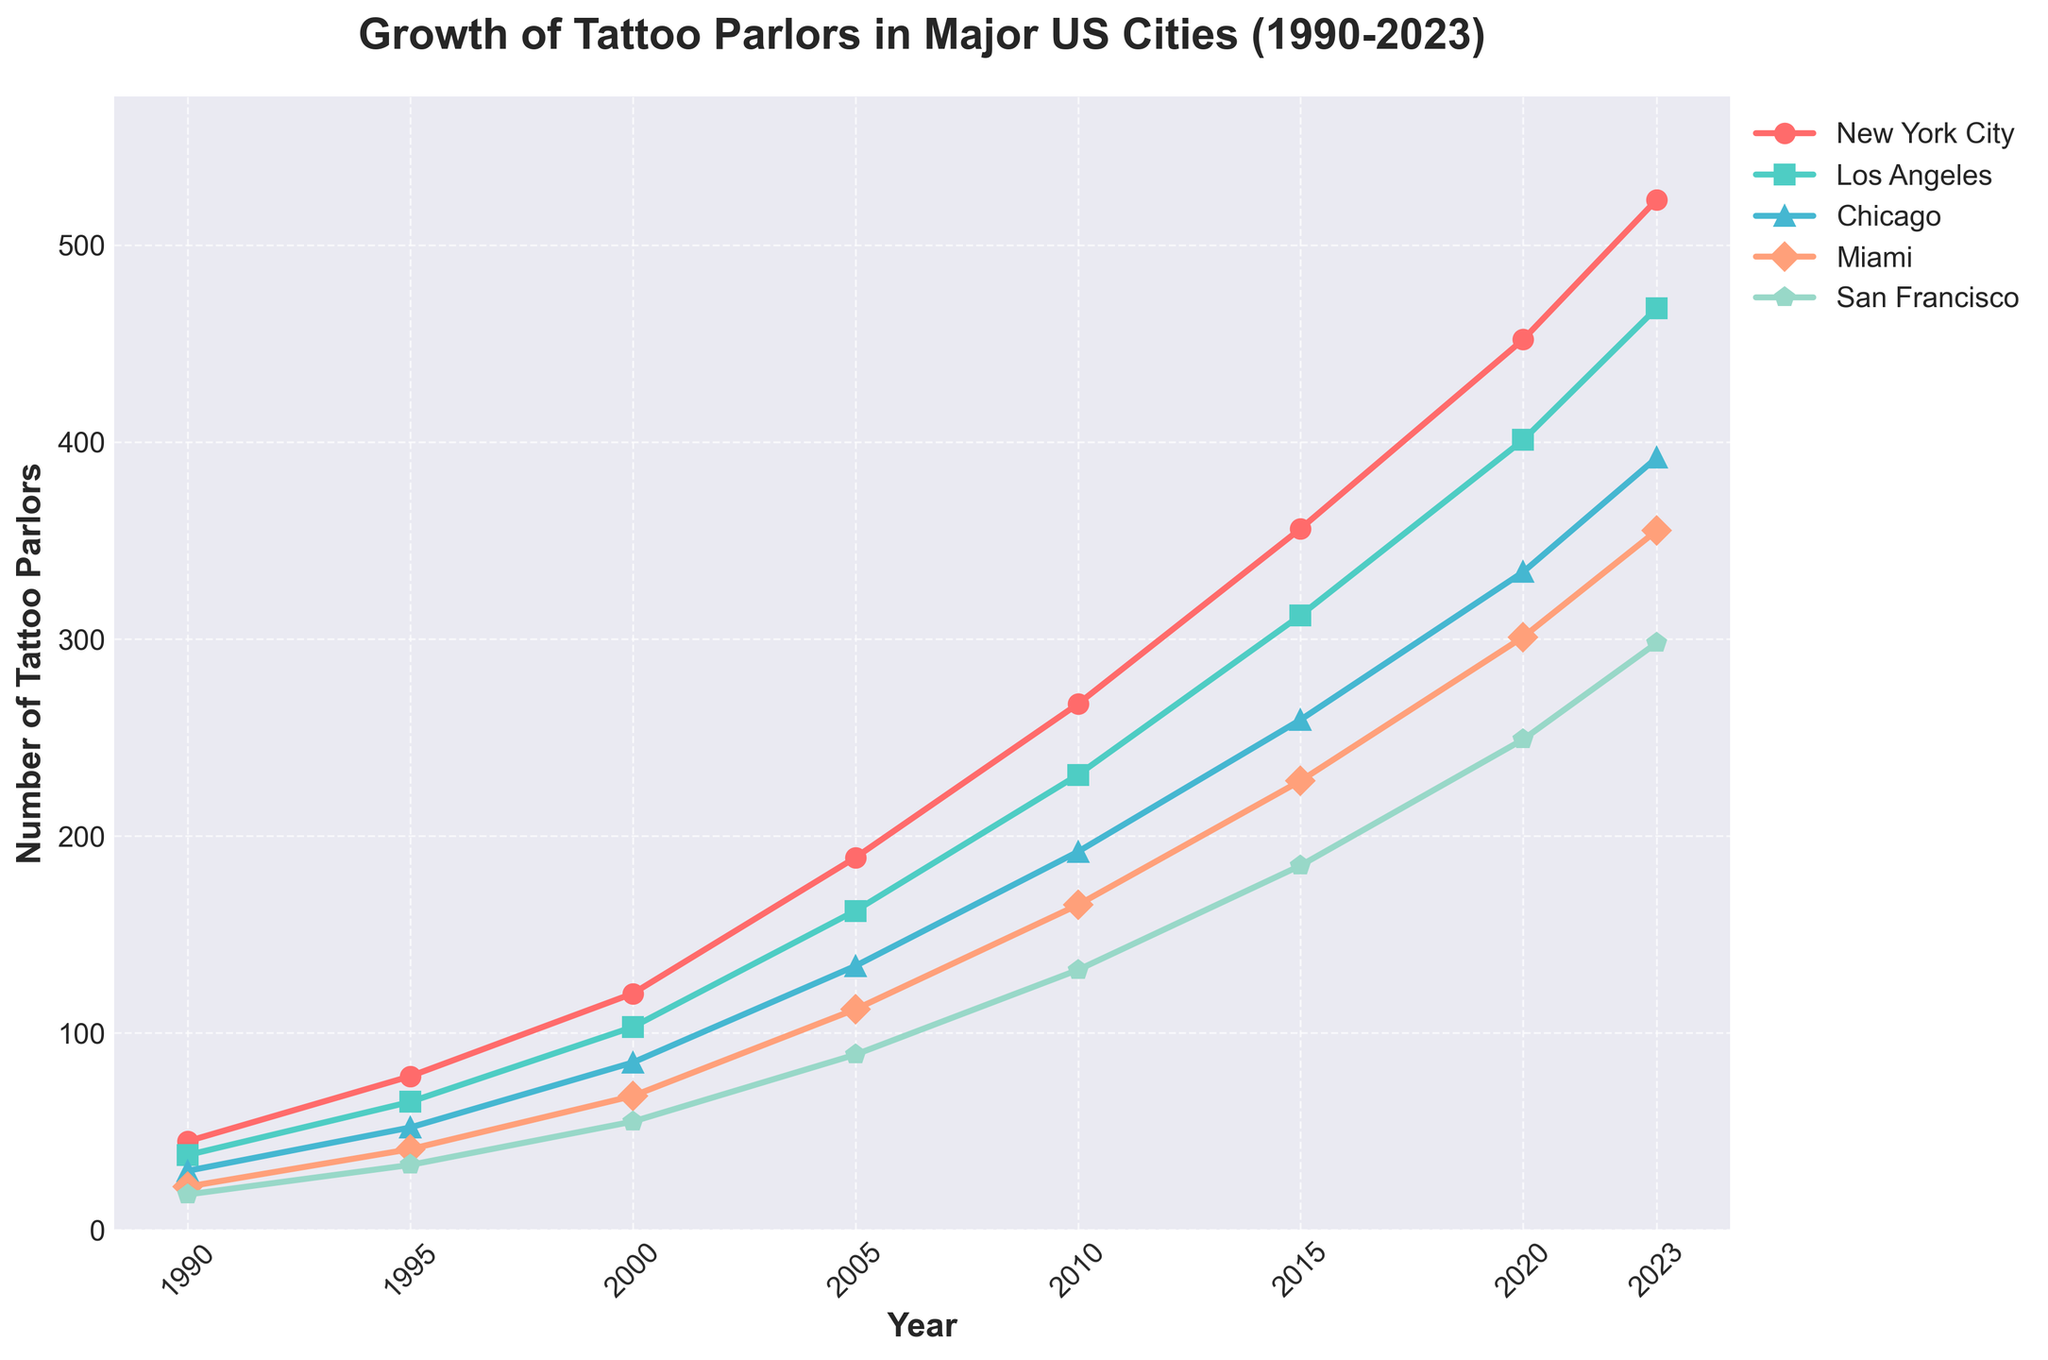Which city had the highest number of tattoo parlors in 2000? Look at the points corresponding to the year 2000 on the chart. The height of the line for New York City is the highest among the cities.
Answer: New York City How many tattoo parlors were there in total across all five cities in 2015? Sum the number of tattoo parlors in each city for the year 2015: 356 (New York City) + 312 (Los Angeles) + 259 (Chicago) + 228 (Miami) + 185 (San Francisco) = 1340.
Answer: 1340 Which city experienced the largest increase in the number of tattoo parlors from 1990 to 2023? Calculate the difference in the number of tattoo parlors for each city between 1990 and 2023: New York City (523 - 45 = 478), Los Angeles (468 - 38 = 430), Chicago (392 - 30 = 362), Miami (355 - 22 = 333), San Francisco (298 - 18 = 280). New York City had the largest increase.
Answer: New York City By how many tattoo parlors did the number in Los Angeles increase from 2000 to 2023? Subtract the number of tattoo parlors in Los Angeles in 2000 from that in 2023: (468 - 103 = 365).
Answer: 365 Which city had the smallest number of tattoo parlors in 1990? Look at the values for the year 1990. San Francisco has the smallest number at 18.
Answer: San Francisco Between which consecutive years did Miami see the highest growth in the number of tattoo parlors? Calculate the difference in the number of tattoo parlors in Miami between consecutive years: 1990-1995 (41 - 22 = 19), 1995-2000 (68 - 41 = 27), 2000-2005 (112 - 68 = 44), 2005-2010 (165 - 112 = 53), 2010-2015 (228 - 165 = 63), 2015-2020 (301 - 228 = 73), 2020-2023 (355 - 301 = 54). The highest growth occurred between 2015 and 2020 with an increase of 73.
Answer: 2015-2020 Which city had a higher number of tattoo parlors in 2010, Chicago or San Francisco? Compare the values for the year 2010: Chicago (192) had more tattoo parlors than San Francisco (132).
Answer: Chicago What was the average number of tattoo parlors in New York City from 2000 to 2023? Sum the number of tattoo parlors in New York City for the years 2000, 2005, 2010, 2015, 2020, and 2023: (120 + 189 + 267 + 356 + 452 + 523) = 1907. Divide by the number of data points, 6: 1907/6 ≈ 317.83.
Answer: 317.83 How does the growth trend in the number of tattoo parlors in San Francisco between 1995 and 2020 appear on the chart? The chart shows an upward trend for San Francisco between 1995 (33) and 2020 (249), indicating a steady increase in the number of tattoo parlors.
Answer: Upward trend 